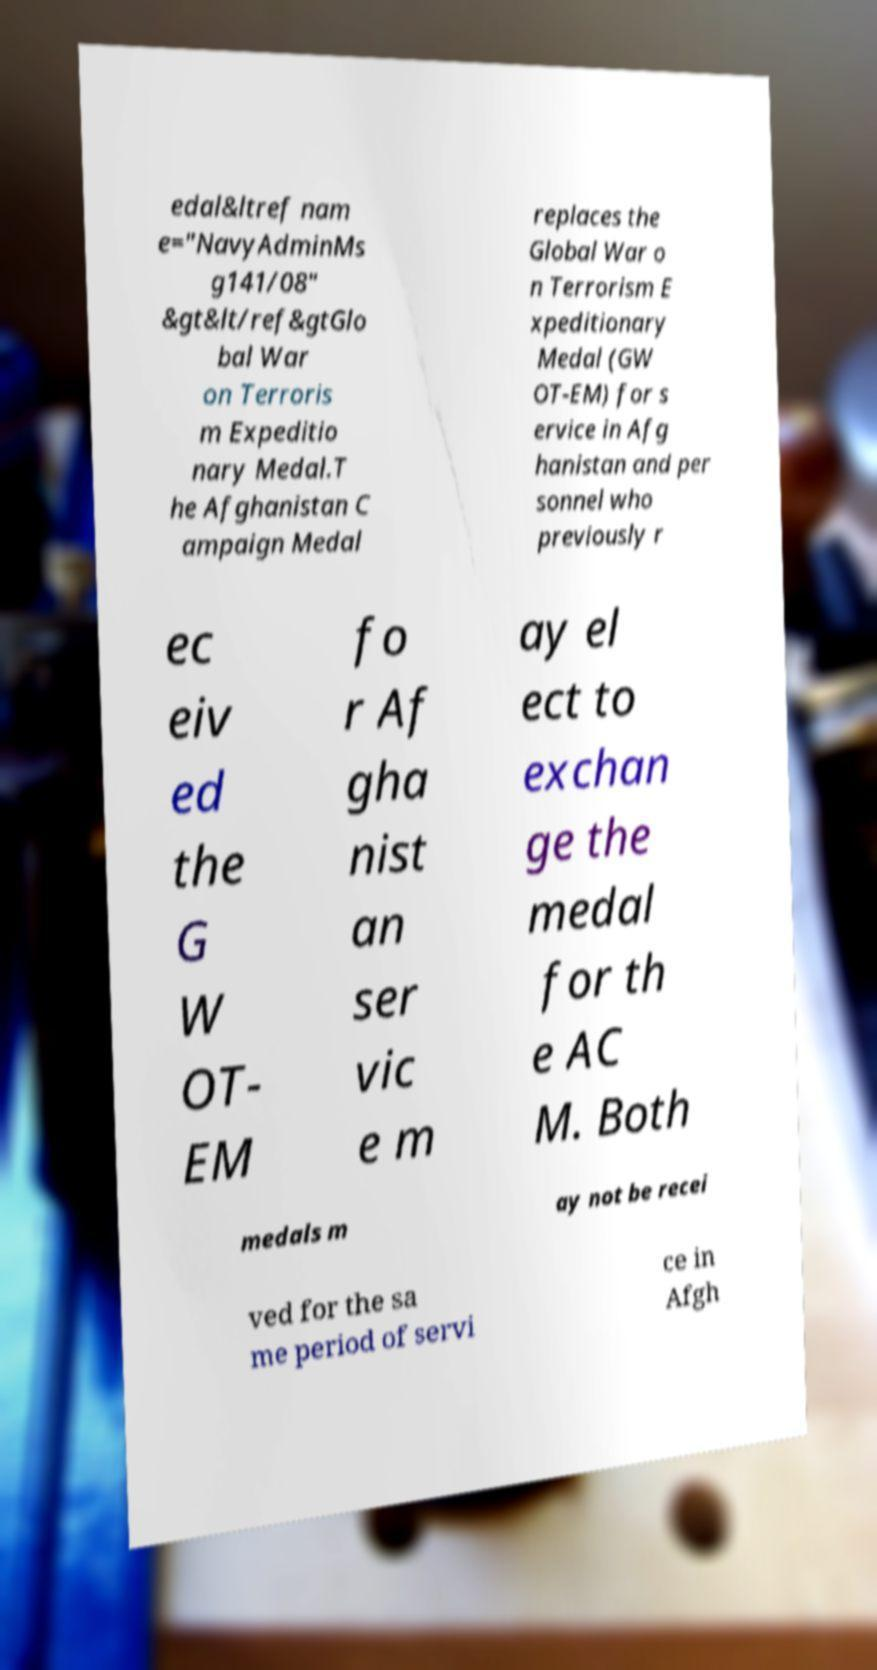What messages or text are displayed in this image? I need them in a readable, typed format. edal&ltref nam e="NavyAdminMs g141/08" &gt&lt/ref&gtGlo bal War on Terroris m Expeditio nary Medal.T he Afghanistan C ampaign Medal replaces the Global War o n Terrorism E xpeditionary Medal (GW OT-EM) for s ervice in Afg hanistan and per sonnel who previously r ec eiv ed the G W OT- EM fo r Af gha nist an ser vic e m ay el ect to exchan ge the medal for th e AC M. Both medals m ay not be recei ved for the sa me period of servi ce in Afgh 